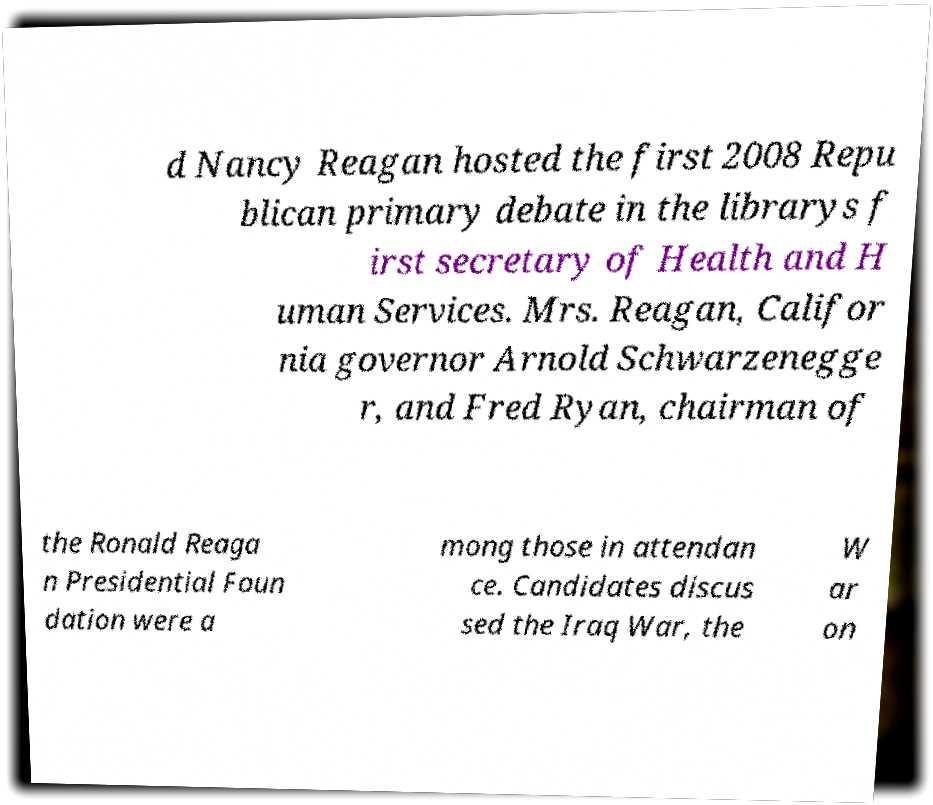Can you read and provide the text displayed in the image?This photo seems to have some interesting text. Can you extract and type it out for me? d Nancy Reagan hosted the first 2008 Repu blican primary debate in the librarys f irst secretary of Health and H uman Services. Mrs. Reagan, Califor nia governor Arnold Schwarzenegge r, and Fred Ryan, chairman of the Ronald Reaga n Presidential Foun dation were a mong those in attendan ce. Candidates discus sed the Iraq War, the W ar on 